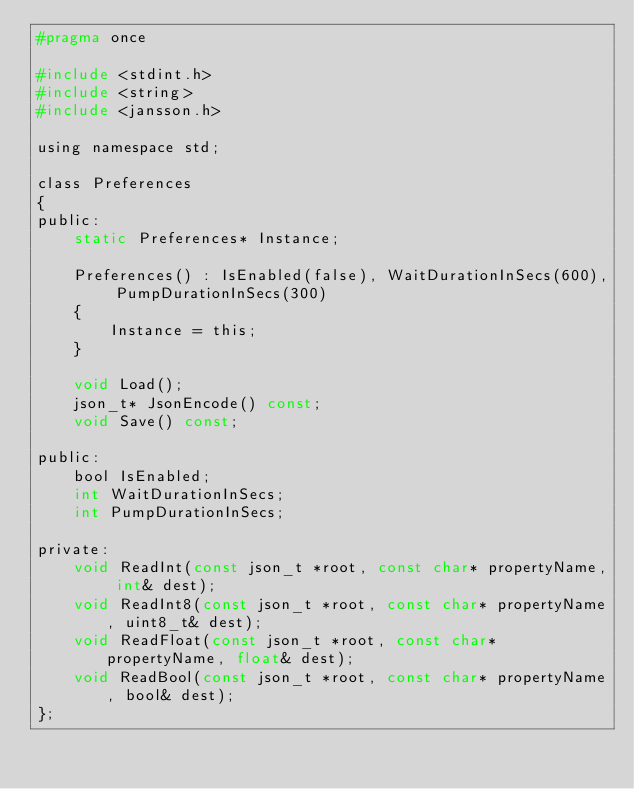<code> <loc_0><loc_0><loc_500><loc_500><_C_>#pragma once

#include <stdint.h>
#include <string>
#include <jansson.h>

using namespace std;

class Preferences
{
public:
	static Preferences* Instance;

	Preferences() : IsEnabled(false), WaitDurationInSecs(600), PumpDurationInSecs(300)
	{
		Instance = this;
	}

	void Load();
	json_t* JsonEncode() const;
	void Save() const;

public:
	bool IsEnabled;
	int WaitDurationInSecs;
	int PumpDurationInSecs;

private:
	void ReadInt(const json_t *root, const char* propertyName, int& dest);
	void ReadInt8(const json_t *root, const char* propertyName, uint8_t& dest);
	void ReadFloat(const json_t *root, const char* propertyName, float& dest);
	void ReadBool(const json_t *root, const char* propertyName, bool& dest);
};
</code> 